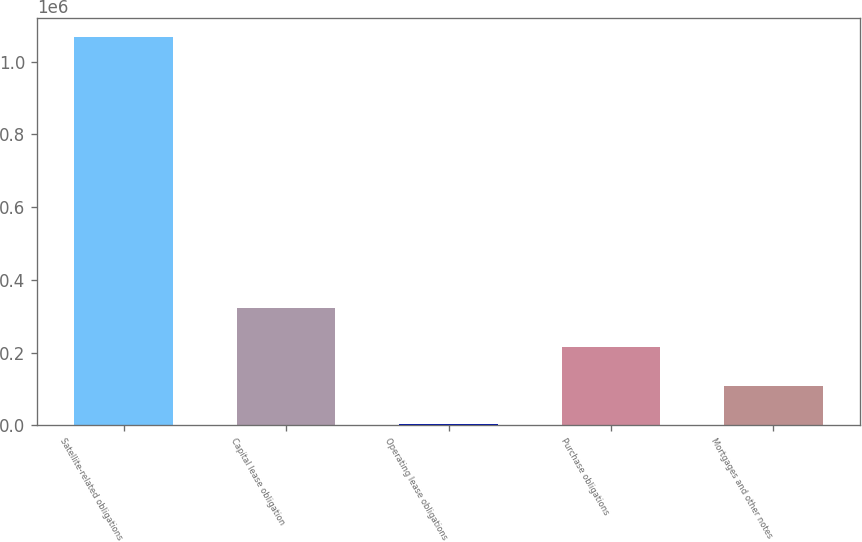Convert chart to OTSL. <chart><loc_0><loc_0><loc_500><loc_500><bar_chart><fcel>Satellite-related obligations<fcel>Capital lease obligation<fcel>Operating lease obligations<fcel>Purchase obligations<fcel>Mortgages and other notes<nl><fcel>1.06746e+06<fcel>322028<fcel>2559<fcel>215538<fcel>109049<nl></chart> 